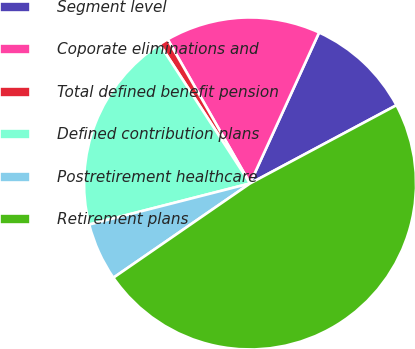Convert chart to OTSL. <chart><loc_0><loc_0><loc_500><loc_500><pie_chart><fcel>Segment level<fcel>Coporate eliminations and<fcel>Total defined benefit pension<fcel>Defined contribution plans<fcel>Postretirement healthcare<fcel>Retirement plans<nl><fcel>10.36%<fcel>15.09%<fcel>0.9%<fcel>19.82%<fcel>5.63%<fcel>48.2%<nl></chart> 